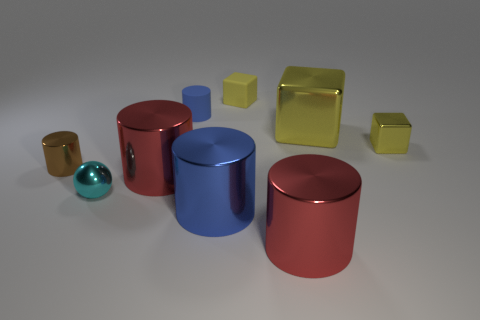Subtract all yellow blocks. How many were subtracted if there are1yellow blocks left? 2 Subtract all brown cylinders. How many cylinders are left? 4 Subtract all brown shiny cylinders. How many cylinders are left? 4 Subtract all gray spheres. Subtract all red cubes. How many spheres are left? 1 Add 1 yellow metallic blocks. How many objects exist? 10 Subtract all cylinders. How many objects are left? 4 Subtract 0 brown spheres. How many objects are left? 9 Subtract all big yellow metal spheres. Subtract all small blue rubber things. How many objects are left? 8 Add 1 rubber cylinders. How many rubber cylinders are left? 2 Add 6 tiny blue cylinders. How many tiny blue cylinders exist? 7 